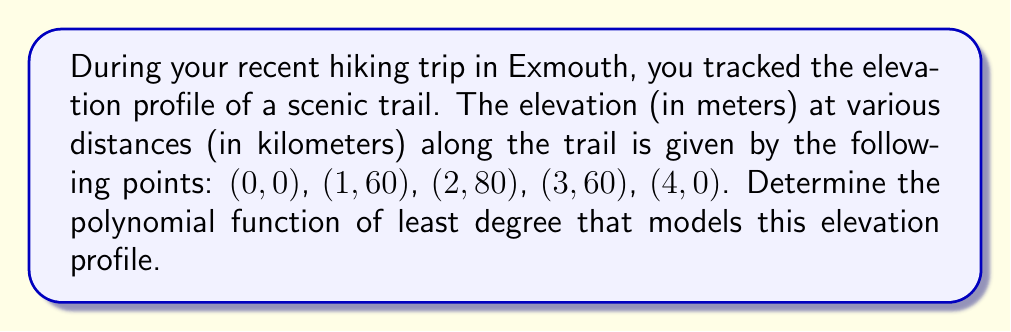Solve this math problem. To find the polynomial function that models the elevation profile, we'll follow these steps:

1) Given the shape of the data points, we can assume this is a 4th-degree polynomial of the form:
   $$f(x) = ax^4 + bx^3 + cx^2 + dx + e$$

2) We have 5 points, so we can create a system of 5 equations:
   $$f(0) = e = 0$$
   $$f(1) = a + b + c + d + e = 60$$
   $$f(2) = 16a + 8b + 4c + 2d + e = 80$$
   $$f(3) = 81a + 27b + 9c + 3d + e = 60$$
   $$f(4) = 256a + 64b + 16c + 4d + e = 0$$

3) From the first equation, we know that $e = 0$. Substituting this into the other equations:
   $$a + b + c + d = 60$$
   $$16a + 8b + 4c + 2d = 80$$
   $$81a + 27b + 9c + 3d = 60$$
   $$256a + 64b + 16c + 4d = 0$$

4) Solving this system of equations (you can use a computer algebra system for this):
   $$a = -5$$
   $$b = 40$$
   $$c = -90$$
   $$d = 60$$

5) Therefore, the polynomial function that models the elevation profile is:
   $$f(x) = -5x^4 + 40x^3 - 90x^2 + 60x$$

You can verify that this function passes through all the given points.
Answer: $f(x) = -5x^4 + 40x^3 - 90x^2 + 60x$ 